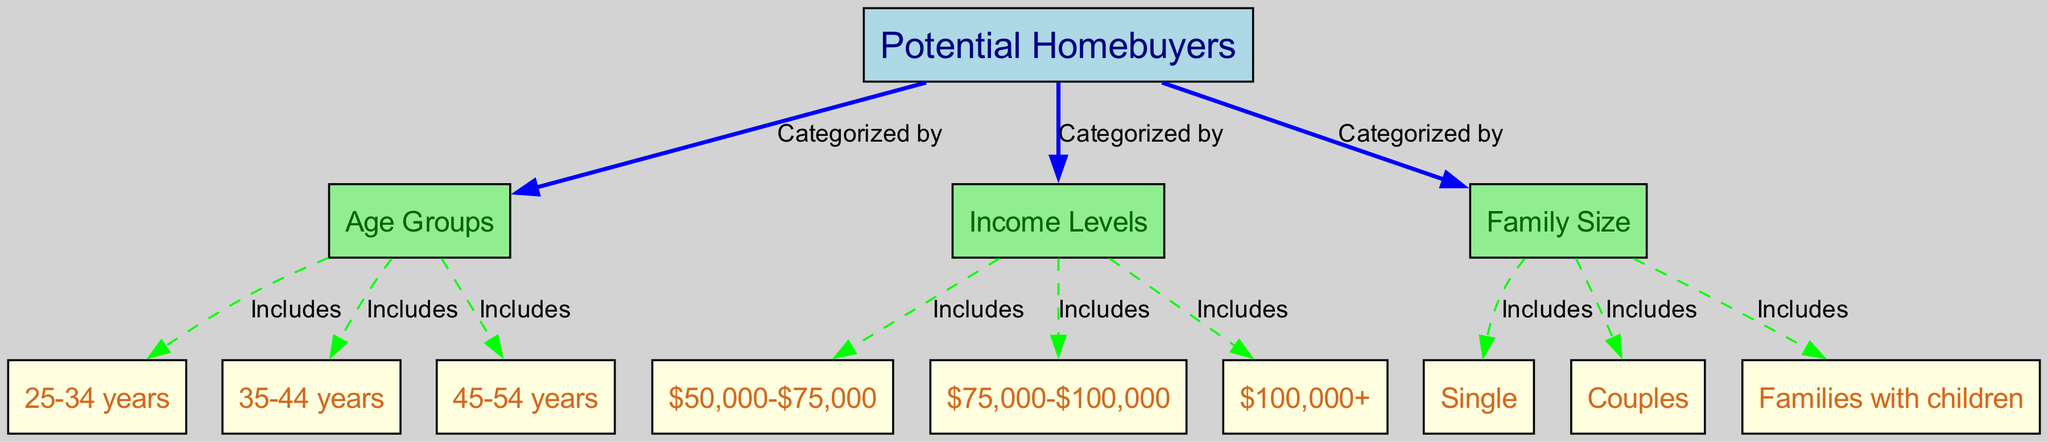What are the three main categories of potential homebuyers in the diagram? The diagram shows three main categories under "Potential Homebuyers": Age Groups, Income Levels, and Family Size. Each category is connected with the label "Categorized by," indicating these are the ways potential homebuyers are classified.
Answer: Age Groups, Income Levels, Family Size How many age groups are identified in the diagram? There are three age groups listed in the diagram: 25-34 years, 35-44 years, and 45-54 years. This can be counted by looking at the nodes directly connected to "Age Groups."
Answer: 3 Which income level is the highest on the diagram? The highest income level listed in the diagram is "$100,000+." By examining the income levels categorized from the "Income Levels" node, "$100,000+" is positioned at the top, indicating it represents the highest range.
Answer: $100,000+ How many family size classifications are present in the diagram? There are three classifications under "Family Size": Single, Couples, and Families with children. This can be confirmed by counting the nodes that are directly associated with the "Family Size" node.
Answer: 3 What relationship does "Income Levels" have with potential homebuyers? The "Income Levels" node is categorized under potential homebuyers, indicating that the income of potential homebuyers is an important factor in understanding their demographics. It is connected with the label "Categorized by," showing that income levels are a defining aspect of potential homebuyers.
Answer: Categorized by Which age group includes 25-34 years? The node labeled "25-34 years" is included in the "Age Groups" section of the diagram, as seen in the relationship denoted by the edge labeled "Includes." This indicates that this specific age group is part of the broader category of age demographics for potential homebuyers.
Answer: Includes What is the relationship between family size and potential homebuyers? The connection between "Family Size" and "Potential Homebuyers" indicates that family size is one of the key classifications used to understand potential homebuyers. The edge labeled "Categorized by" illustrates its role as a demographic factor in analyzing potential homebuyers.
Answer: Categorized by How many edges connect to the "Potential Homebuyers" node? There are three edges connecting to the "Potential Homebuyers" node, corresponding to the classifications for age, income, and family size. Thus, each represents an important demographic aspect of this category.
Answer: 3 Which label describes the relationship between "Age Groups" and its subsets in the diagram? The relationship between "Age Groups" and its subsets is described by the label "Includes." This label indicates that the nodes representing specific age ranges are part of the broader category of "Age Groups."
Answer: Includes 